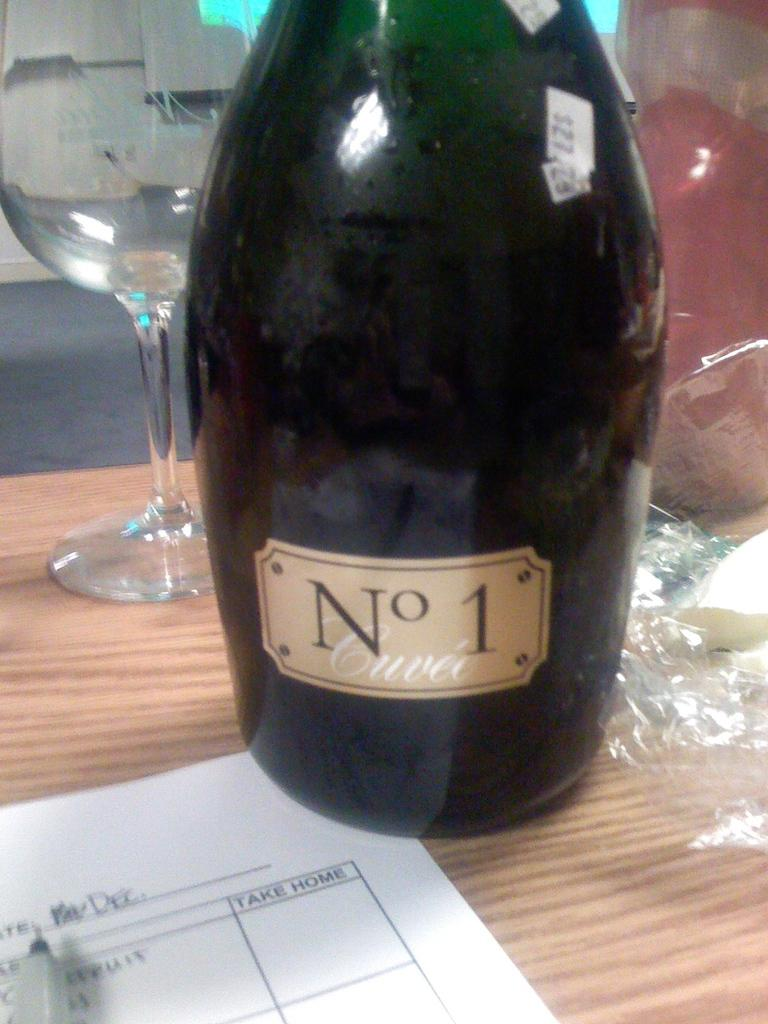Provide a one-sentence caption for the provided image. A bottle of No 1 Cuvee sits on a table in front of wine glass and next to a paper that has a column named Take Home. 